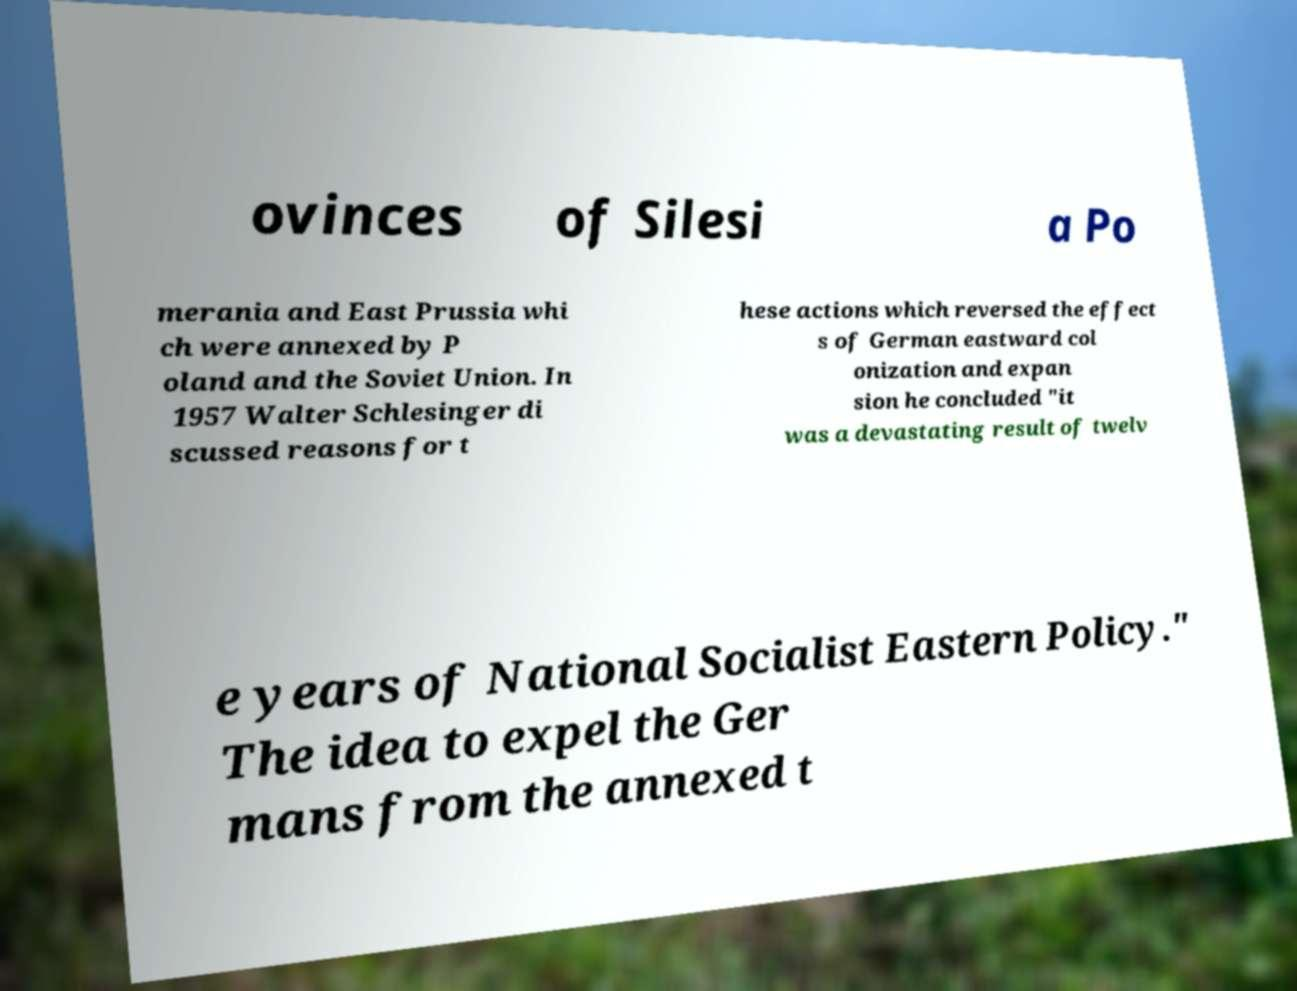Could you extract and type out the text from this image? ovinces of Silesi a Po merania and East Prussia whi ch were annexed by P oland and the Soviet Union. In 1957 Walter Schlesinger di scussed reasons for t hese actions which reversed the effect s of German eastward col onization and expan sion he concluded "it was a devastating result of twelv e years of National Socialist Eastern Policy." The idea to expel the Ger mans from the annexed t 